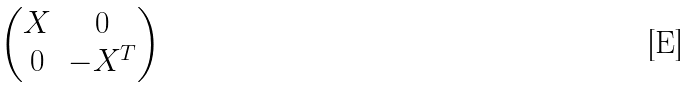<formula> <loc_0><loc_0><loc_500><loc_500>\begin{pmatrix} X & 0 \\ 0 & - X ^ { T } \\ \end{pmatrix}</formula> 